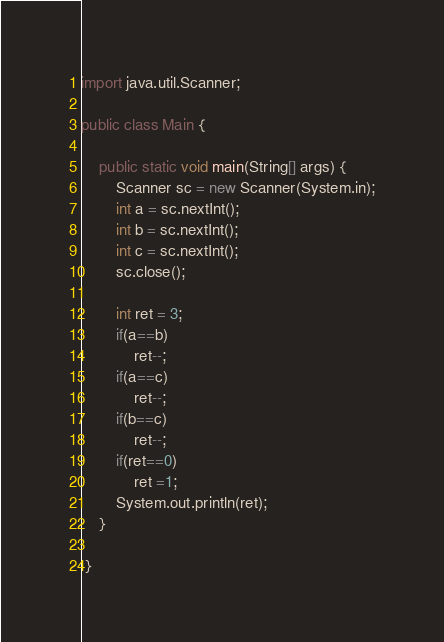<code> <loc_0><loc_0><loc_500><loc_500><_Java_>import java.util.Scanner;

public class Main {

    public static void main(String[] args) {
        Scanner sc = new Scanner(System.in);
        int a = sc.nextInt();
        int b = sc.nextInt();
        int c = sc.nextInt();
        sc.close();
        
        int ret = 3;
        if(a==b)
            ret--;
        if(a==c)
            ret--;
        if(b==c)
            ret--;
        if(ret==0)
            ret =1;
        System.out.println(ret);
    }
    
 }</code> 